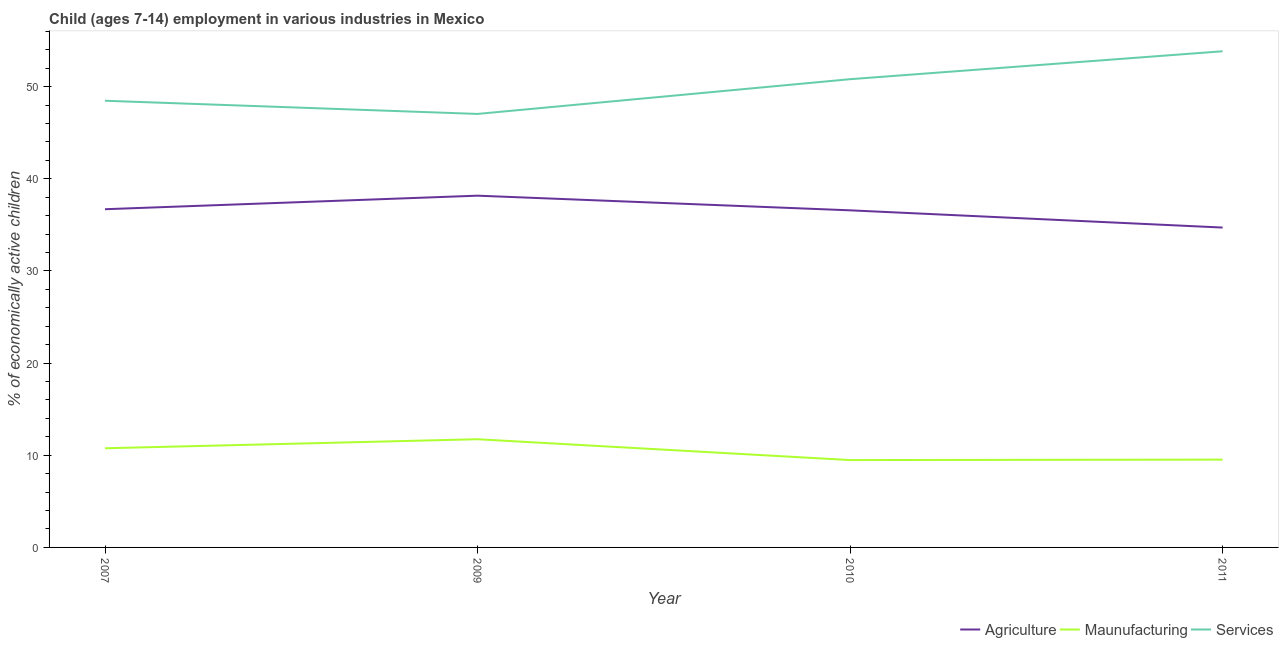How many different coloured lines are there?
Keep it short and to the point. 3. Is the number of lines equal to the number of legend labels?
Your response must be concise. Yes. What is the percentage of economically active children in manufacturing in 2011?
Make the answer very short. 9.53. Across all years, what is the maximum percentage of economically active children in agriculture?
Your response must be concise. 38.17. Across all years, what is the minimum percentage of economically active children in agriculture?
Offer a very short reply. 34.71. What is the total percentage of economically active children in manufacturing in the graph?
Your answer should be compact. 41.51. What is the difference between the percentage of economically active children in agriculture in 2007 and that in 2010?
Give a very brief answer. 0.12. What is the difference between the percentage of economically active children in agriculture in 2007 and the percentage of economically active children in services in 2010?
Keep it short and to the point. -14.11. What is the average percentage of economically active children in services per year?
Provide a succinct answer. 50.04. In the year 2011, what is the difference between the percentage of economically active children in agriculture and percentage of economically active children in manufacturing?
Offer a terse response. 25.18. In how many years, is the percentage of economically active children in services greater than 12 %?
Your response must be concise. 4. What is the ratio of the percentage of economically active children in services in 2007 to that in 2009?
Offer a terse response. 1.03. Is the percentage of economically active children in manufacturing in 2007 less than that in 2010?
Provide a short and direct response. No. What is the difference between the highest and the second highest percentage of economically active children in services?
Provide a succinct answer. 3.03. What is the difference between the highest and the lowest percentage of economically active children in manufacturing?
Offer a terse response. 2.26. Is it the case that in every year, the sum of the percentage of economically active children in agriculture and percentage of economically active children in manufacturing is greater than the percentage of economically active children in services?
Offer a terse response. No. Is the percentage of economically active children in manufacturing strictly greater than the percentage of economically active children in agriculture over the years?
Provide a short and direct response. No. How many lines are there?
Your response must be concise. 3. How many years are there in the graph?
Ensure brevity in your answer.  4. Does the graph contain any zero values?
Ensure brevity in your answer.  No. Does the graph contain grids?
Your answer should be compact. No. Where does the legend appear in the graph?
Provide a succinct answer. Bottom right. How many legend labels are there?
Your response must be concise. 3. What is the title of the graph?
Ensure brevity in your answer.  Child (ages 7-14) employment in various industries in Mexico. Does "Manufactures" appear as one of the legend labels in the graph?
Keep it short and to the point. No. What is the label or title of the Y-axis?
Your response must be concise. % of economically active children. What is the % of economically active children of Agriculture in 2007?
Your response must be concise. 36.7. What is the % of economically active children in Maunufacturing in 2007?
Offer a terse response. 10.76. What is the % of economically active children in Services in 2007?
Your answer should be very brief. 48.47. What is the % of economically active children in Agriculture in 2009?
Give a very brief answer. 38.17. What is the % of economically active children of Maunufacturing in 2009?
Offer a very short reply. 11.74. What is the % of economically active children of Services in 2009?
Provide a succinct answer. 47.04. What is the % of economically active children in Agriculture in 2010?
Offer a terse response. 36.58. What is the % of economically active children of Maunufacturing in 2010?
Your response must be concise. 9.48. What is the % of economically active children of Services in 2010?
Provide a succinct answer. 50.81. What is the % of economically active children of Agriculture in 2011?
Your response must be concise. 34.71. What is the % of economically active children in Maunufacturing in 2011?
Keep it short and to the point. 9.53. What is the % of economically active children of Services in 2011?
Provide a short and direct response. 53.84. Across all years, what is the maximum % of economically active children in Agriculture?
Provide a short and direct response. 38.17. Across all years, what is the maximum % of economically active children of Maunufacturing?
Offer a terse response. 11.74. Across all years, what is the maximum % of economically active children of Services?
Your response must be concise. 53.84. Across all years, what is the minimum % of economically active children in Agriculture?
Your answer should be very brief. 34.71. Across all years, what is the minimum % of economically active children of Maunufacturing?
Provide a short and direct response. 9.48. Across all years, what is the minimum % of economically active children in Services?
Provide a succinct answer. 47.04. What is the total % of economically active children in Agriculture in the graph?
Offer a terse response. 146.16. What is the total % of economically active children of Maunufacturing in the graph?
Provide a short and direct response. 41.51. What is the total % of economically active children of Services in the graph?
Your answer should be very brief. 200.16. What is the difference between the % of economically active children of Agriculture in 2007 and that in 2009?
Keep it short and to the point. -1.47. What is the difference between the % of economically active children in Maunufacturing in 2007 and that in 2009?
Ensure brevity in your answer.  -0.98. What is the difference between the % of economically active children of Services in 2007 and that in 2009?
Your answer should be very brief. 1.43. What is the difference between the % of economically active children of Agriculture in 2007 and that in 2010?
Make the answer very short. 0.12. What is the difference between the % of economically active children of Maunufacturing in 2007 and that in 2010?
Keep it short and to the point. 1.28. What is the difference between the % of economically active children of Services in 2007 and that in 2010?
Your answer should be very brief. -2.34. What is the difference between the % of economically active children in Agriculture in 2007 and that in 2011?
Make the answer very short. 1.99. What is the difference between the % of economically active children in Maunufacturing in 2007 and that in 2011?
Give a very brief answer. 1.23. What is the difference between the % of economically active children in Services in 2007 and that in 2011?
Provide a short and direct response. -5.37. What is the difference between the % of economically active children in Agriculture in 2009 and that in 2010?
Offer a very short reply. 1.59. What is the difference between the % of economically active children in Maunufacturing in 2009 and that in 2010?
Provide a succinct answer. 2.26. What is the difference between the % of economically active children of Services in 2009 and that in 2010?
Ensure brevity in your answer.  -3.77. What is the difference between the % of economically active children in Agriculture in 2009 and that in 2011?
Your answer should be very brief. 3.46. What is the difference between the % of economically active children in Maunufacturing in 2009 and that in 2011?
Ensure brevity in your answer.  2.21. What is the difference between the % of economically active children of Services in 2009 and that in 2011?
Offer a terse response. -6.8. What is the difference between the % of economically active children of Agriculture in 2010 and that in 2011?
Ensure brevity in your answer.  1.87. What is the difference between the % of economically active children of Services in 2010 and that in 2011?
Your answer should be compact. -3.03. What is the difference between the % of economically active children of Agriculture in 2007 and the % of economically active children of Maunufacturing in 2009?
Your response must be concise. 24.96. What is the difference between the % of economically active children in Agriculture in 2007 and the % of economically active children in Services in 2009?
Your answer should be compact. -10.34. What is the difference between the % of economically active children in Maunufacturing in 2007 and the % of economically active children in Services in 2009?
Ensure brevity in your answer.  -36.28. What is the difference between the % of economically active children of Agriculture in 2007 and the % of economically active children of Maunufacturing in 2010?
Give a very brief answer. 27.22. What is the difference between the % of economically active children in Agriculture in 2007 and the % of economically active children in Services in 2010?
Offer a very short reply. -14.11. What is the difference between the % of economically active children in Maunufacturing in 2007 and the % of economically active children in Services in 2010?
Keep it short and to the point. -40.05. What is the difference between the % of economically active children of Agriculture in 2007 and the % of economically active children of Maunufacturing in 2011?
Provide a short and direct response. 27.17. What is the difference between the % of economically active children in Agriculture in 2007 and the % of economically active children in Services in 2011?
Provide a succinct answer. -17.14. What is the difference between the % of economically active children of Maunufacturing in 2007 and the % of economically active children of Services in 2011?
Make the answer very short. -43.08. What is the difference between the % of economically active children in Agriculture in 2009 and the % of economically active children in Maunufacturing in 2010?
Ensure brevity in your answer.  28.69. What is the difference between the % of economically active children in Agriculture in 2009 and the % of economically active children in Services in 2010?
Your answer should be very brief. -12.64. What is the difference between the % of economically active children in Maunufacturing in 2009 and the % of economically active children in Services in 2010?
Keep it short and to the point. -39.07. What is the difference between the % of economically active children of Agriculture in 2009 and the % of economically active children of Maunufacturing in 2011?
Offer a very short reply. 28.64. What is the difference between the % of economically active children of Agriculture in 2009 and the % of economically active children of Services in 2011?
Offer a very short reply. -15.67. What is the difference between the % of economically active children in Maunufacturing in 2009 and the % of economically active children in Services in 2011?
Offer a terse response. -42.1. What is the difference between the % of economically active children of Agriculture in 2010 and the % of economically active children of Maunufacturing in 2011?
Make the answer very short. 27.05. What is the difference between the % of economically active children in Agriculture in 2010 and the % of economically active children in Services in 2011?
Your response must be concise. -17.26. What is the difference between the % of economically active children of Maunufacturing in 2010 and the % of economically active children of Services in 2011?
Provide a short and direct response. -44.36. What is the average % of economically active children of Agriculture per year?
Provide a short and direct response. 36.54. What is the average % of economically active children in Maunufacturing per year?
Offer a terse response. 10.38. What is the average % of economically active children of Services per year?
Your response must be concise. 50.04. In the year 2007, what is the difference between the % of economically active children of Agriculture and % of economically active children of Maunufacturing?
Your answer should be very brief. 25.94. In the year 2007, what is the difference between the % of economically active children in Agriculture and % of economically active children in Services?
Your answer should be very brief. -11.77. In the year 2007, what is the difference between the % of economically active children in Maunufacturing and % of economically active children in Services?
Provide a short and direct response. -37.71. In the year 2009, what is the difference between the % of economically active children of Agriculture and % of economically active children of Maunufacturing?
Offer a terse response. 26.43. In the year 2009, what is the difference between the % of economically active children of Agriculture and % of economically active children of Services?
Your response must be concise. -8.87. In the year 2009, what is the difference between the % of economically active children in Maunufacturing and % of economically active children in Services?
Offer a terse response. -35.3. In the year 2010, what is the difference between the % of economically active children of Agriculture and % of economically active children of Maunufacturing?
Keep it short and to the point. 27.1. In the year 2010, what is the difference between the % of economically active children in Agriculture and % of economically active children in Services?
Provide a succinct answer. -14.23. In the year 2010, what is the difference between the % of economically active children in Maunufacturing and % of economically active children in Services?
Your answer should be very brief. -41.33. In the year 2011, what is the difference between the % of economically active children in Agriculture and % of economically active children in Maunufacturing?
Your answer should be very brief. 25.18. In the year 2011, what is the difference between the % of economically active children of Agriculture and % of economically active children of Services?
Keep it short and to the point. -19.13. In the year 2011, what is the difference between the % of economically active children of Maunufacturing and % of economically active children of Services?
Ensure brevity in your answer.  -44.31. What is the ratio of the % of economically active children of Agriculture in 2007 to that in 2009?
Make the answer very short. 0.96. What is the ratio of the % of economically active children of Maunufacturing in 2007 to that in 2009?
Keep it short and to the point. 0.92. What is the ratio of the % of economically active children of Services in 2007 to that in 2009?
Provide a succinct answer. 1.03. What is the ratio of the % of economically active children in Agriculture in 2007 to that in 2010?
Your response must be concise. 1. What is the ratio of the % of economically active children in Maunufacturing in 2007 to that in 2010?
Offer a very short reply. 1.14. What is the ratio of the % of economically active children of Services in 2007 to that in 2010?
Your answer should be compact. 0.95. What is the ratio of the % of economically active children in Agriculture in 2007 to that in 2011?
Ensure brevity in your answer.  1.06. What is the ratio of the % of economically active children of Maunufacturing in 2007 to that in 2011?
Your answer should be very brief. 1.13. What is the ratio of the % of economically active children of Services in 2007 to that in 2011?
Provide a succinct answer. 0.9. What is the ratio of the % of economically active children in Agriculture in 2009 to that in 2010?
Offer a very short reply. 1.04. What is the ratio of the % of economically active children in Maunufacturing in 2009 to that in 2010?
Your answer should be compact. 1.24. What is the ratio of the % of economically active children in Services in 2009 to that in 2010?
Make the answer very short. 0.93. What is the ratio of the % of economically active children of Agriculture in 2009 to that in 2011?
Offer a terse response. 1.1. What is the ratio of the % of economically active children in Maunufacturing in 2009 to that in 2011?
Your answer should be very brief. 1.23. What is the ratio of the % of economically active children of Services in 2009 to that in 2011?
Offer a very short reply. 0.87. What is the ratio of the % of economically active children of Agriculture in 2010 to that in 2011?
Your answer should be compact. 1.05. What is the ratio of the % of economically active children of Maunufacturing in 2010 to that in 2011?
Ensure brevity in your answer.  0.99. What is the ratio of the % of economically active children in Services in 2010 to that in 2011?
Make the answer very short. 0.94. What is the difference between the highest and the second highest % of economically active children of Agriculture?
Your answer should be compact. 1.47. What is the difference between the highest and the second highest % of economically active children in Services?
Keep it short and to the point. 3.03. What is the difference between the highest and the lowest % of economically active children of Agriculture?
Give a very brief answer. 3.46. What is the difference between the highest and the lowest % of economically active children of Maunufacturing?
Give a very brief answer. 2.26. What is the difference between the highest and the lowest % of economically active children of Services?
Your answer should be very brief. 6.8. 